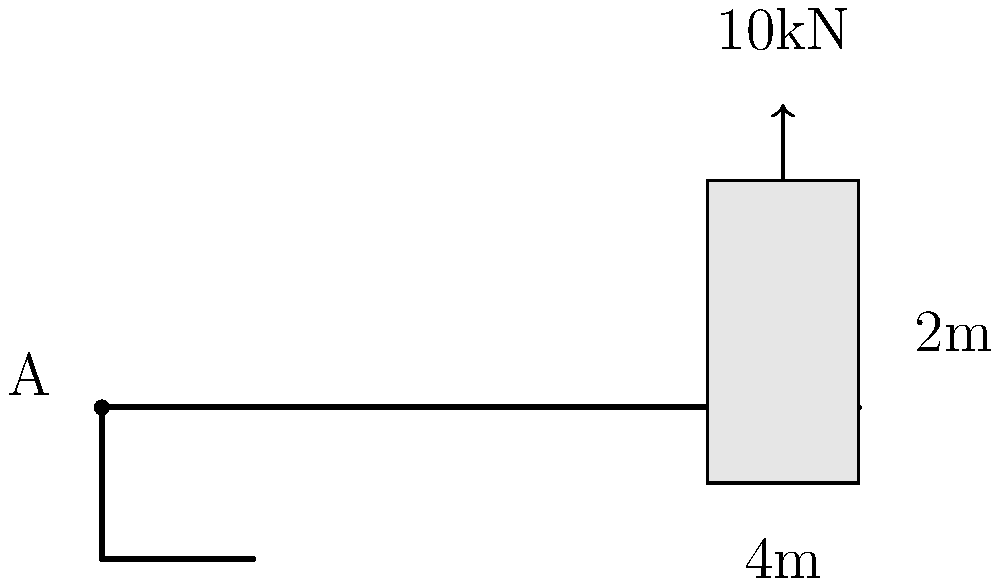As a civil engineer working on the new FC DAC 1904 Dunajská Streda stadium, you need to design the cantilever support for the scoreboard. The scoreboard weighs 10 kN and is mounted at the end of a 4m long cantilever beam. The scoreboard's dimensions are 2m x 4m. Calculate the maximum bending moment at point A of the cantilever beam. Assume the weight of the beam is negligible compared to the scoreboard. To calculate the maximum bending moment at point A of the cantilever beam, we'll follow these steps:

1) First, we need to understand that the maximum bending moment occurs at the fixed end of a cantilever beam, which is point A in this case.

2) The bending moment is caused by the weight of the scoreboard acting at a distance from point A.

3) The formula for bending moment is:

   $M = F \times d$

   Where:
   $M$ = Bending moment
   $F$ = Force (weight of the scoreboard)
   $d$ = Distance from the point of force application to the point of interest

4) We're given:
   - Force (F) = 10 kN (weight of the scoreboard)
   - Distance (d) = 4 m (length of the cantilever)

5) Plugging these values into the formula:

   $M = 10 \text{ kN} \times 4 \text{ m} = 40 \text{ kN}\cdot\text{m}$

Therefore, the maximum bending moment at point A is 40 kN·m.
Answer: 40 kN·m 